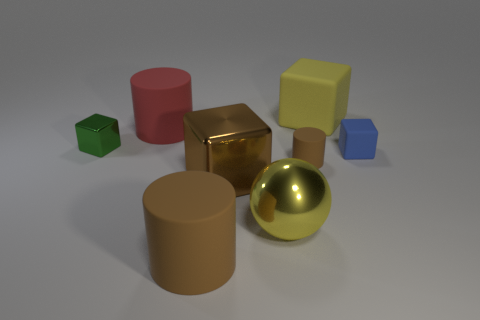How many metallic things are spheres or small purple balls?
Your answer should be very brief. 1. There is a tiny blue rubber object; what shape is it?
Keep it short and to the point. Cube. Is the material of the small brown cylinder the same as the tiny green cube?
Keep it short and to the point. No. Are there any yellow things to the left of the big matte cylinder behind the metallic block that is right of the red cylinder?
Make the answer very short. No. What number of other things are there of the same shape as the large brown metal thing?
Ensure brevity in your answer.  3. There is a small object that is both on the right side of the green block and to the left of the tiny blue rubber cube; what shape is it?
Your response must be concise. Cylinder. There is a block that is behind the matte cylinder that is behind the small block that is to the right of the red rubber cylinder; what is its color?
Keep it short and to the point. Yellow. Are there more blue cubes that are in front of the brown cube than large rubber cylinders that are behind the large brown matte object?
Provide a short and direct response. No. What number of other things are the same size as the yellow ball?
Your answer should be compact. 4. The cube that is the same color as the metal ball is what size?
Keep it short and to the point. Large. 